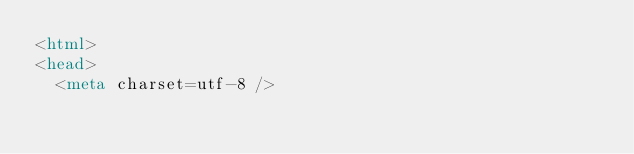<code> <loc_0><loc_0><loc_500><loc_500><_HTML_><html>
<head>
  <meta charset=utf-8 /></code> 